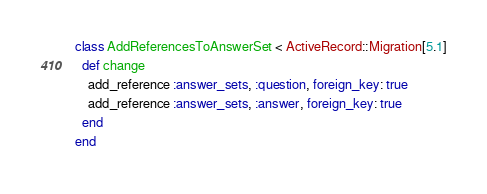Convert code to text. <code><loc_0><loc_0><loc_500><loc_500><_Ruby_>class AddReferencesToAnswerSet < ActiveRecord::Migration[5.1]
  def change
    add_reference :answer_sets, :question, foreign_key: true
    add_reference :answer_sets, :answer, foreign_key: true
  end
end
</code> 